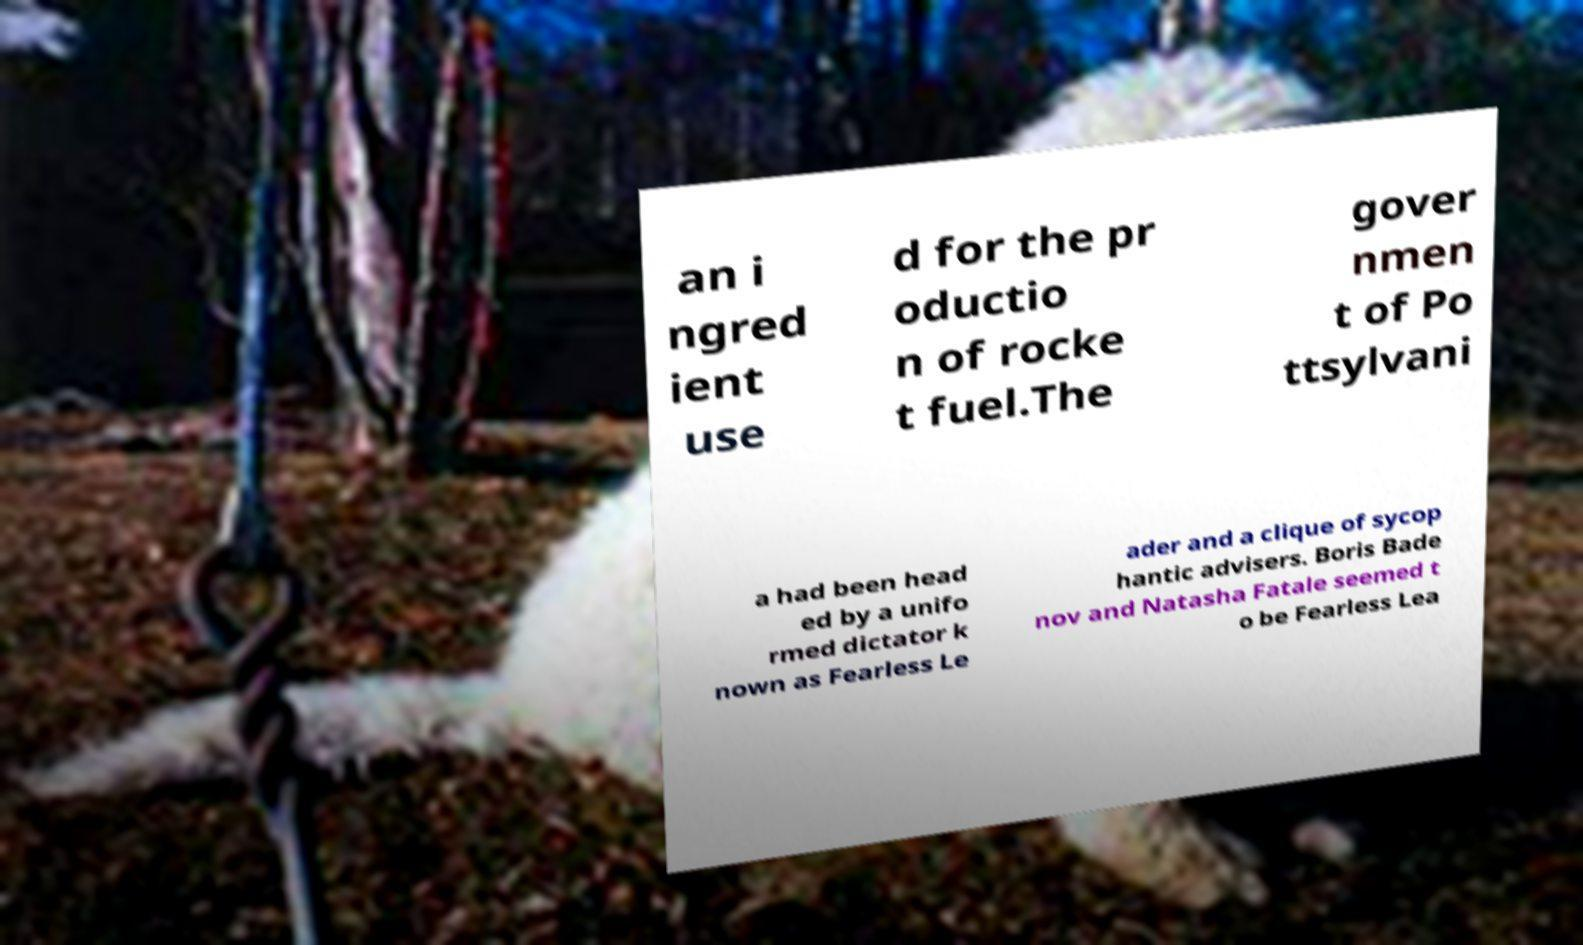I need the written content from this picture converted into text. Can you do that? an i ngred ient use d for the pr oductio n of rocke t fuel.The gover nmen t of Po ttsylvani a had been head ed by a unifo rmed dictator k nown as Fearless Le ader and a clique of sycop hantic advisers. Boris Bade nov and Natasha Fatale seemed t o be Fearless Lea 